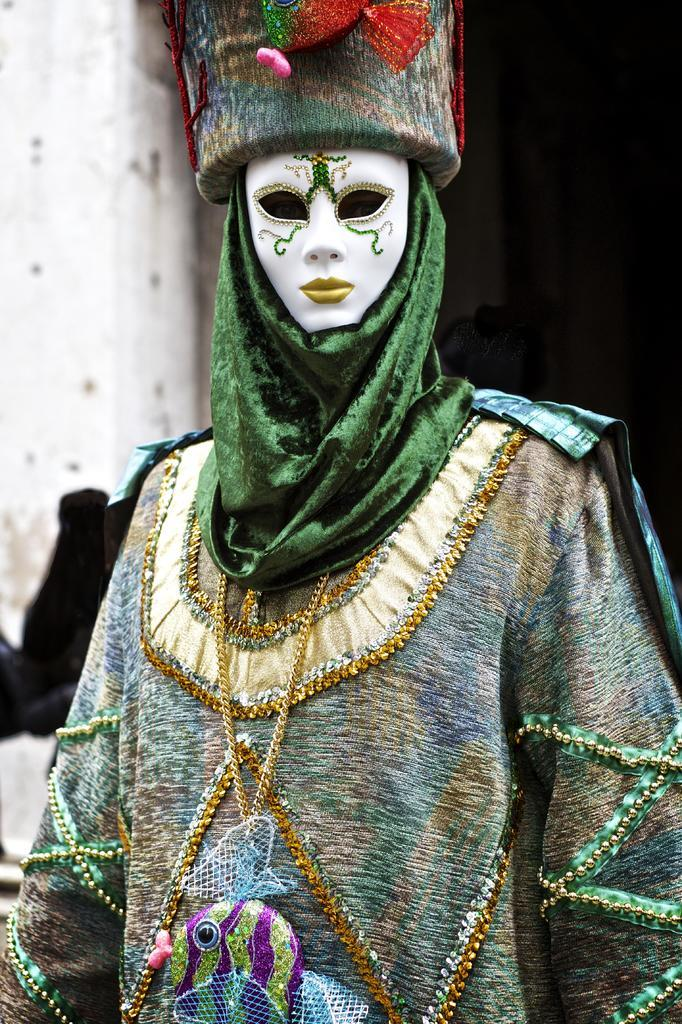What is present in the image? There is a person in the image. What is distinctive about the person's appearance? The person is wearing a costume and a mask. What type of fang can be seen in the image? There is no fang present in the image. How many balloons are visible in the image? There is no mention of balloons in the provided facts, so it cannot be determined how many, if any, are visible in the image. 